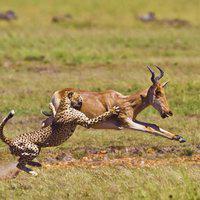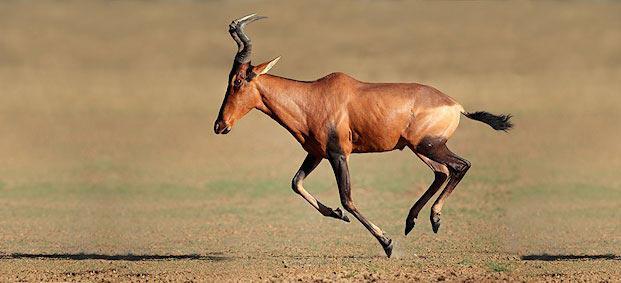The first image is the image on the left, the second image is the image on the right. Evaluate the accuracy of this statement regarding the images: "At least one antelope has its legs up in the air.". Is it true? Answer yes or no. Yes. The first image is the image on the left, the second image is the image on the right. Analyze the images presented: Is the assertion "There are at most two hartebeests." valid? Answer yes or no. Yes. 